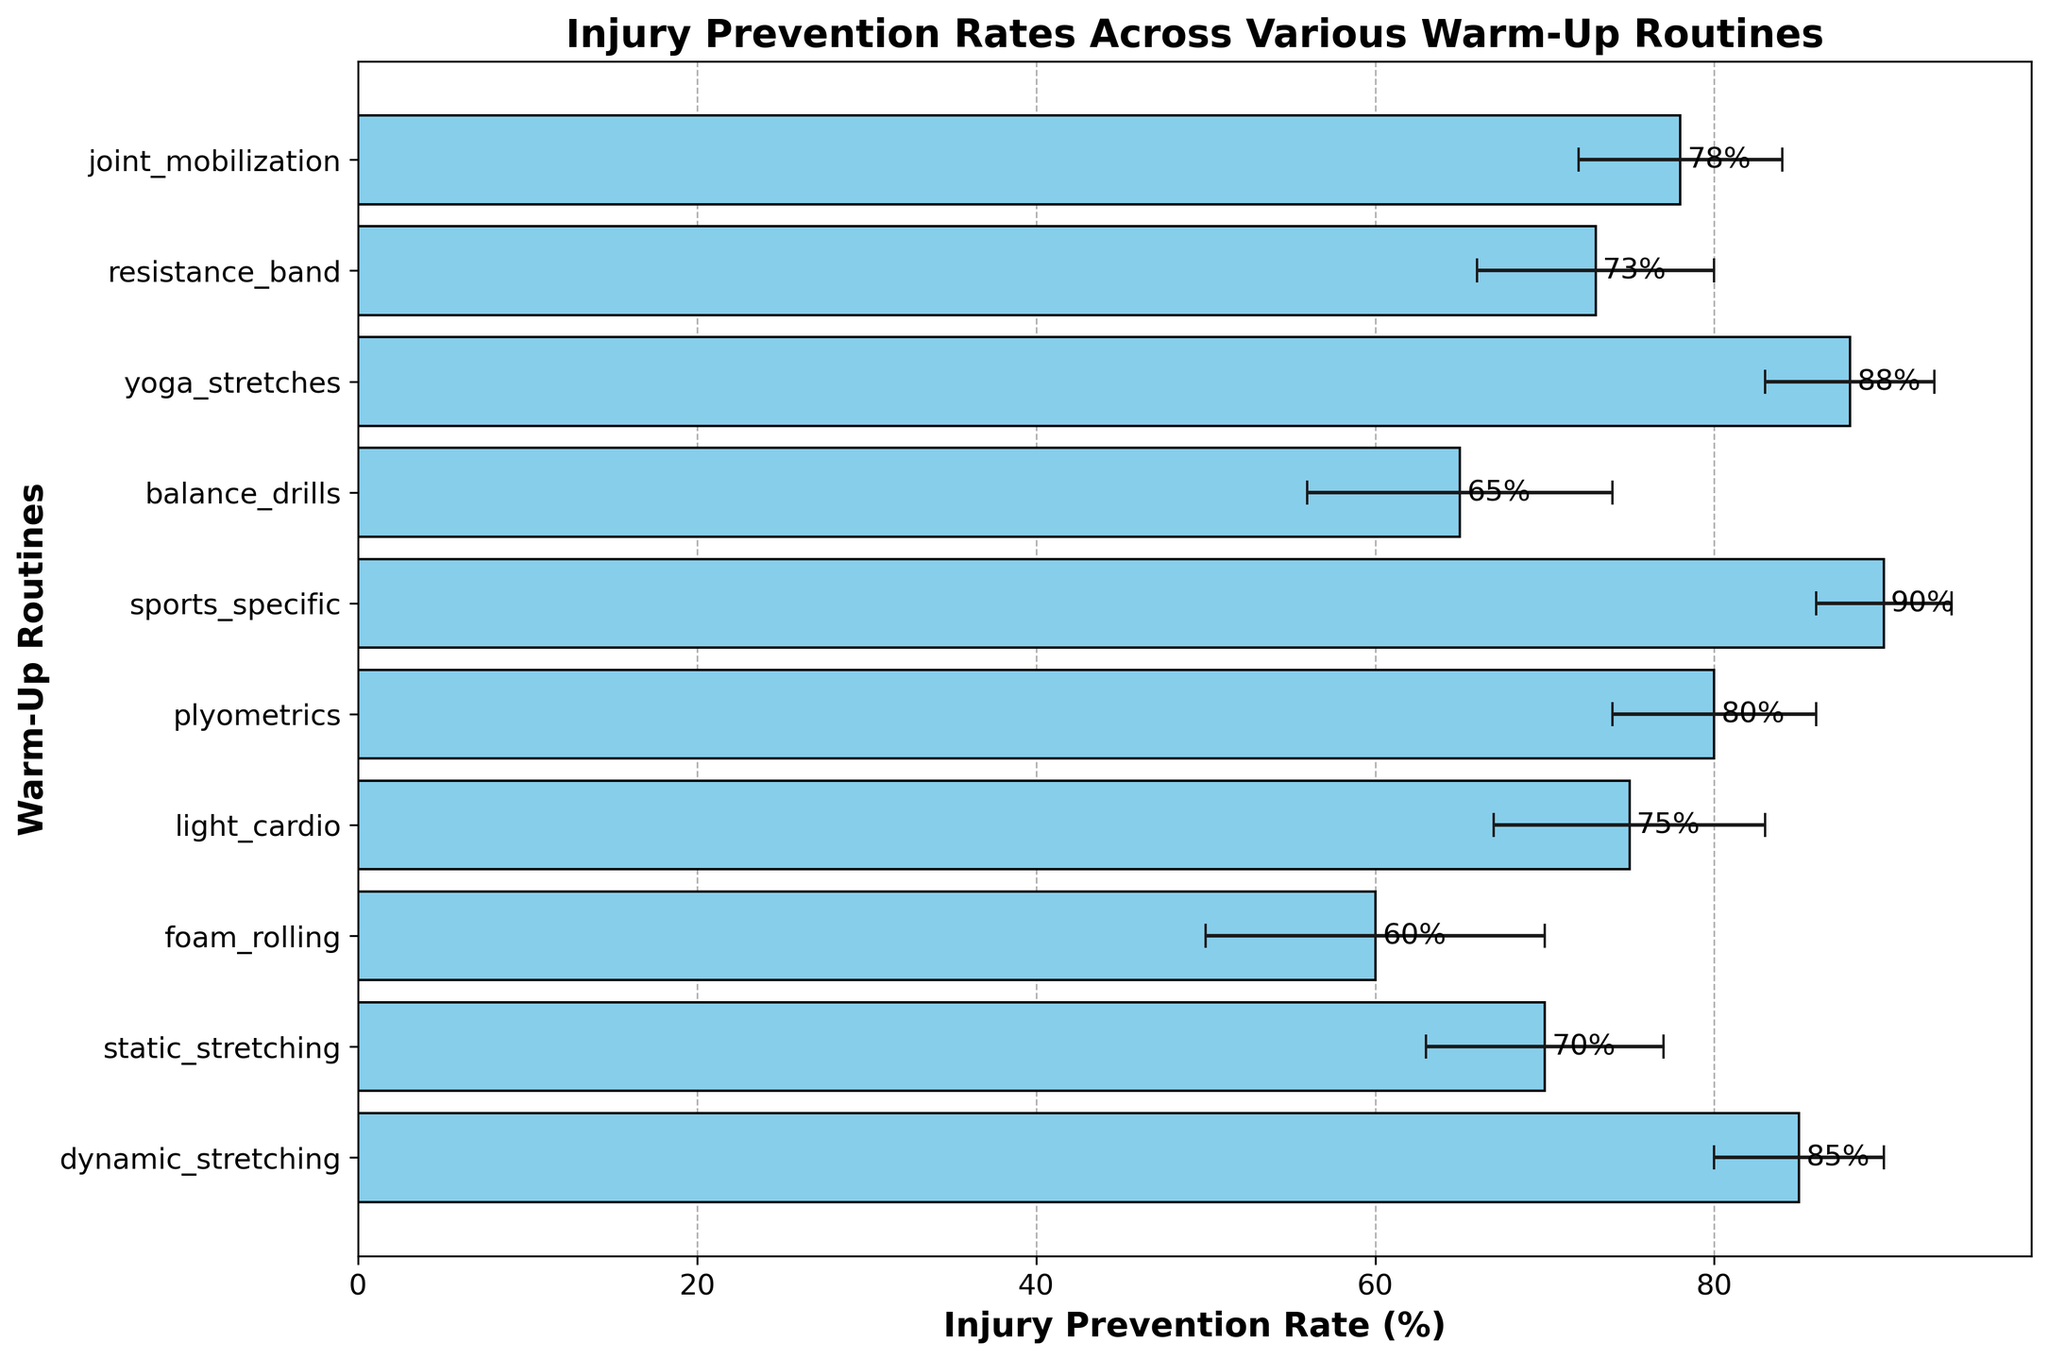Which warm-up routine has the highest injury prevention rate? Look at the bars in the chart and identify the one that reaches the farthest to the right. The sports-specific routine has the highest value.
Answer: sports-specific What is the difference in injury prevention rate between static stretching and dynamic stretching? Subtract the injury prevention rate of static stretching (70%) from that of dynamic stretching (85%). 85 - 70 gives the difference.
Answer: 15% Which warm-up routine has the lowest injury prevention rate, and what is it? Identify the bar that extends the least to the right. The foam rolling routine has the lowest value, observed from the length of its bar.
Answer: foam rolling, 60% Compare the injury prevention rates of yoga stretches and static stretching. Which one is higher and by how much? Subtract the rate of static stretching (70%) from that of yoga stretches (88%). 88 - 70 gives the difference, and yoga stretches is higher.
Answer: yoga stretches, 18% Among the routines listed, which three have the highest injury prevention rates? Inspect the lengths of all bars and pick the three longest. They are sports-specific (90%), yoga stretches (88%), and dynamic stretching (85%).
Answer: sports-specific, yoga stretches, dynamic stretching What is the average injury prevention rate of all the routines combined? Add all the injury prevention rates and then divide by the number of routines. (85 + 70 + 60 + 75 + 80 + 90 + 65 + 88 + 73 + 78) / 10 = 764 / 10. The average is 76.4%.
Answer: 76.4% Which routine has the largest error bar, indicating the greatest variability in injury prevention rate? Identify the bar with the widest error margin represented by the horizontal lines. The foam rolling routine has the largest error bar at 10%.
Answer: foam rolling Is the injury prevention rate of balance drills greater than, less than, or equal to that of light cardio? Compare the lengths of the balance drills (65%) and light cardio (75%) bars. Light cardio is greater.
Answer: less than What is the total injury prevention rate for light cardio and resistance band routines? Add the rates for light cardio (75%) and resistance band (73%). 75 + 73 gives the total.
Answer: 148% What is the range of injury prevention rates among all the routines? Subtract the smallest rate (foam rolling, 60%) from the largest rate (sports-specific, 90%) to find the range. 90 - 60 results in the range.
Answer: 30% 